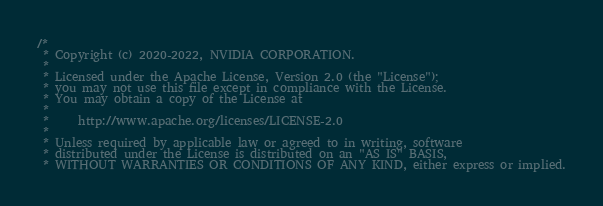Convert code to text. <code><loc_0><loc_0><loc_500><loc_500><_Cuda_>/*
 * Copyright (c) 2020-2022, NVIDIA CORPORATION.
 *
 * Licensed under the Apache License, Version 2.0 (the "License");
 * you may not use this file except in compliance with the License.
 * You may obtain a copy of the License at
 *
 *     http://www.apache.org/licenses/LICENSE-2.0
 *
 * Unless required by applicable law or agreed to in writing, software
 * distributed under the License is distributed on an "AS IS" BASIS,
 * WITHOUT WARRANTIES OR CONDITIONS OF ANY KIND, either express or implied.</code> 